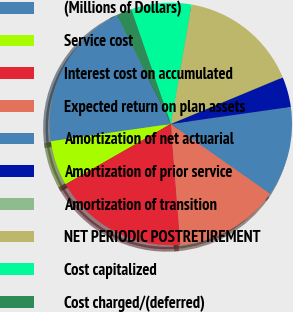Convert chart. <chart><loc_0><loc_0><loc_500><loc_500><pie_chart><fcel>(Millions of Dollars)<fcel>Service cost<fcel>Interest cost on accumulated<fcel>Expected return on plan assets<fcel>Amortization of net actuarial<fcel>Amortization of prior service<fcel>Amortization of transition<fcel>NET PERIODIC POSTRETIREMENT<fcel>Cost capitalized<fcel>Cost charged/(deferred)<nl><fcel>19.97%<fcel>6.01%<fcel>17.98%<fcel>13.99%<fcel>11.99%<fcel>4.02%<fcel>0.03%<fcel>15.98%<fcel>8.01%<fcel>2.02%<nl></chart> 